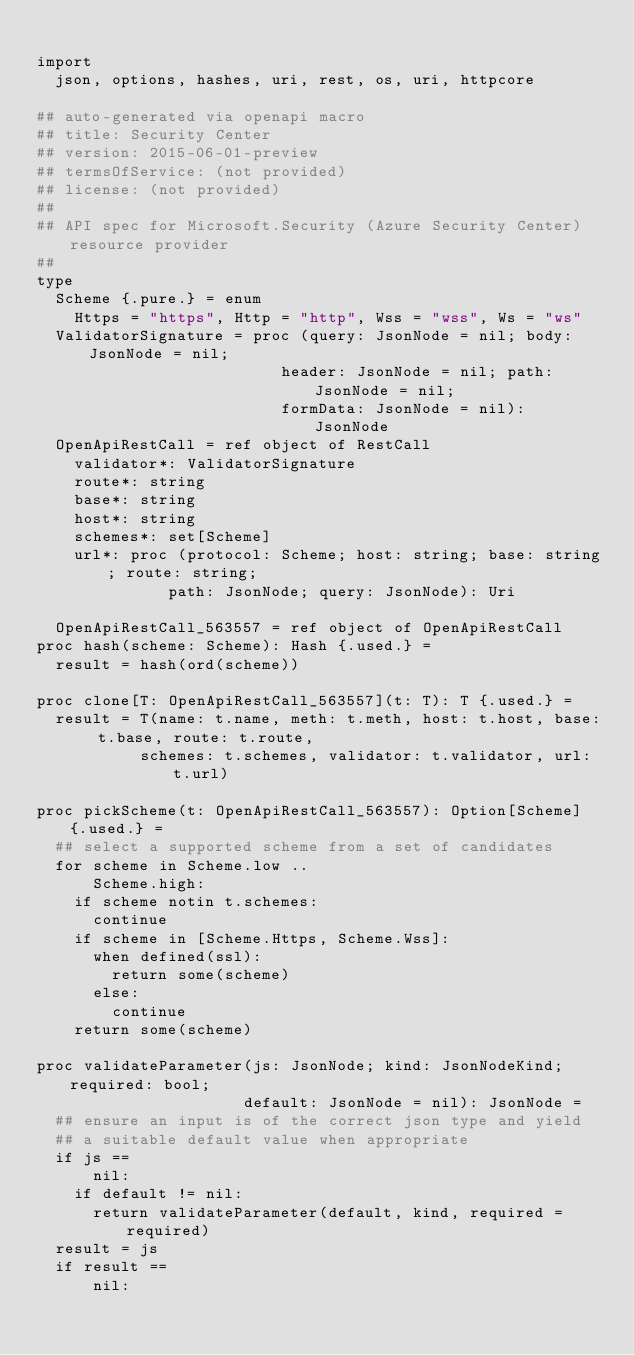Convert code to text. <code><loc_0><loc_0><loc_500><loc_500><_Nim_>
import
  json, options, hashes, uri, rest, os, uri, httpcore

## auto-generated via openapi macro
## title: Security Center
## version: 2015-06-01-preview
## termsOfService: (not provided)
## license: (not provided)
## 
## API spec for Microsoft.Security (Azure Security Center) resource provider
## 
type
  Scheme {.pure.} = enum
    Https = "https", Http = "http", Wss = "wss", Ws = "ws"
  ValidatorSignature = proc (query: JsonNode = nil; body: JsonNode = nil;
                          header: JsonNode = nil; path: JsonNode = nil;
                          formData: JsonNode = nil): JsonNode
  OpenApiRestCall = ref object of RestCall
    validator*: ValidatorSignature
    route*: string
    base*: string
    host*: string
    schemes*: set[Scheme]
    url*: proc (protocol: Scheme; host: string; base: string; route: string;
              path: JsonNode; query: JsonNode): Uri

  OpenApiRestCall_563557 = ref object of OpenApiRestCall
proc hash(scheme: Scheme): Hash {.used.} =
  result = hash(ord(scheme))

proc clone[T: OpenApiRestCall_563557](t: T): T {.used.} =
  result = T(name: t.name, meth: t.meth, host: t.host, base: t.base, route: t.route,
           schemes: t.schemes, validator: t.validator, url: t.url)

proc pickScheme(t: OpenApiRestCall_563557): Option[Scheme] {.used.} =
  ## select a supported scheme from a set of candidates
  for scheme in Scheme.low ..
      Scheme.high:
    if scheme notin t.schemes:
      continue
    if scheme in [Scheme.Https, Scheme.Wss]:
      when defined(ssl):
        return some(scheme)
      else:
        continue
    return some(scheme)

proc validateParameter(js: JsonNode; kind: JsonNodeKind; required: bool;
                      default: JsonNode = nil): JsonNode =
  ## ensure an input is of the correct json type and yield
  ## a suitable default value when appropriate
  if js ==
      nil:
    if default != nil:
      return validateParameter(default, kind, required = required)
  result = js
  if result ==
      nil:</code> 